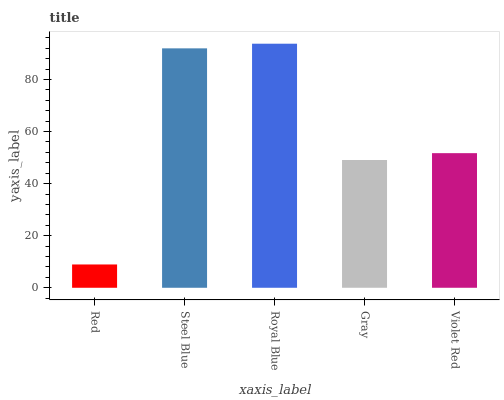Is Red the minimum?
Answer yes or no. Yes. Is Royal Blue the maximum?
Answer yes or no. Yes. Is Steel Blue the minimum?
Answer yes or no. No. Is Steel Blue the maximum?
Answer yes or no. No. Is Steel Blue greater than Red?
Answer yes or no. Yes. Is Red less than Steel Blue?
Answer yes or no. Yes. Is Red greater than Steel Blue?
Answer yes or no. No. Is Steel Blue less than Red?
Answer yes or no. No. Is Violet Red the high median?
Answer yes or no. Yes. Is Violet Red the low median?
Answer yes or no. Yes. Is Royal Blue the high median?
Answer yes or no. No. Is Gray the low median?
Answer yes or no. No. 